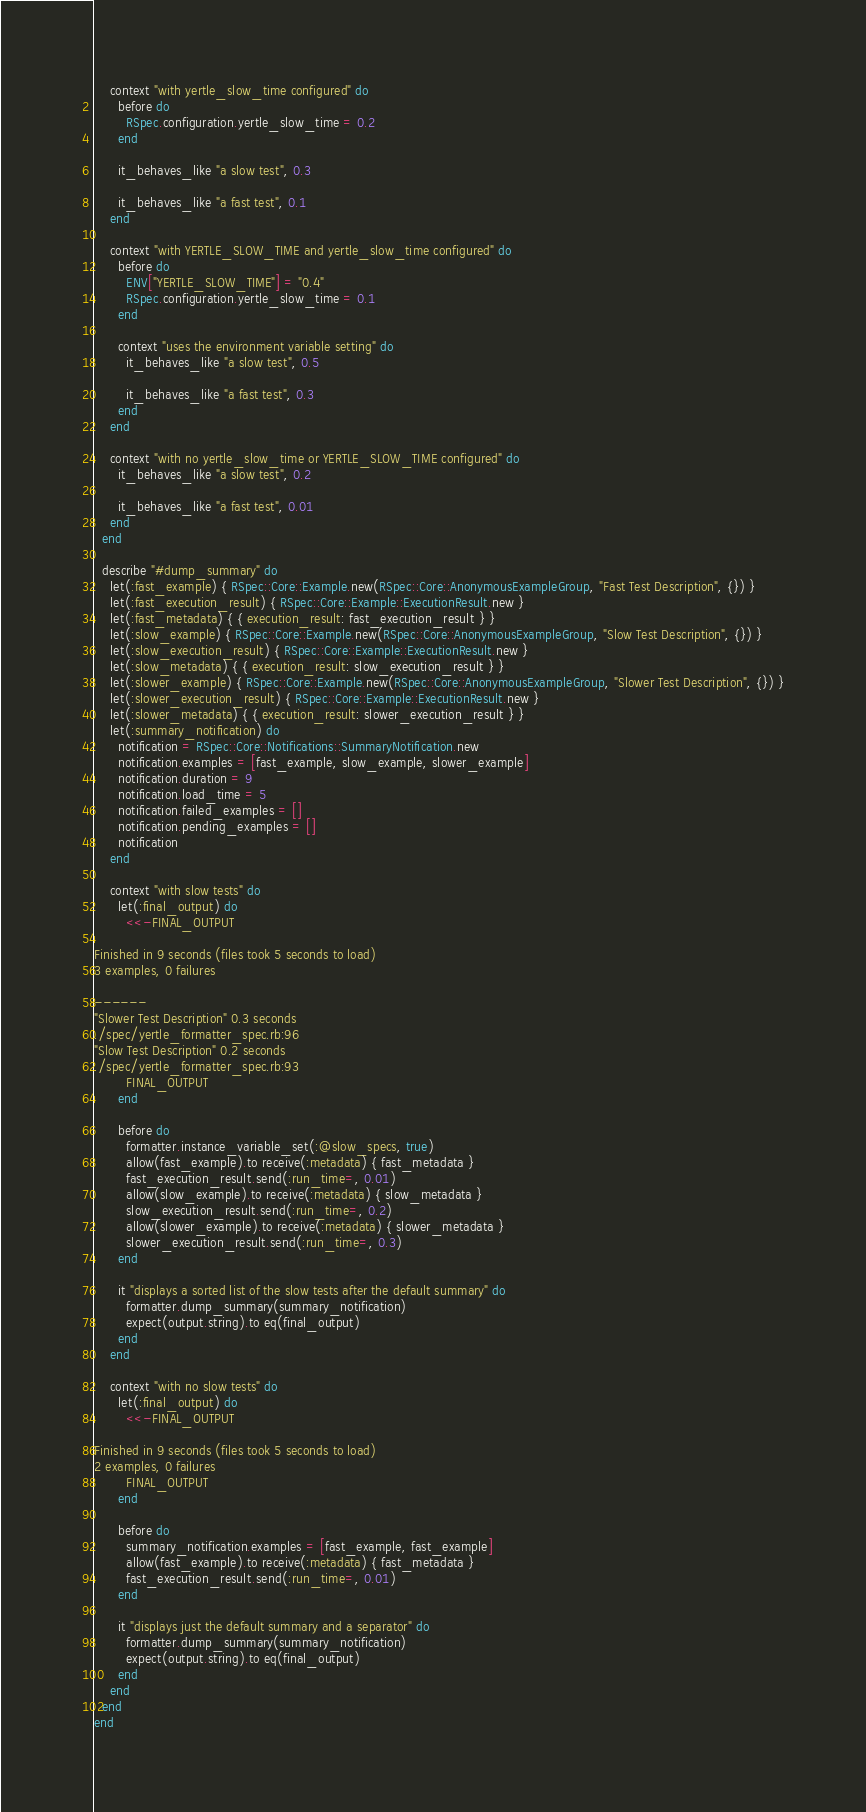Convert code to text. <code><loc_0><loc_0><loc_500><loc_500><_Ruby_>    context "with yertle_slow_time configured" do
      before do
        RSpec.configuration.yertle_slow_time = 0.2
      end

      it_behaves_like "a slow test", 0.3

      it_behaves_like "a fast test", 0.1
    end

    context "with YERTLE_SLOW_TIME and yertle_slow_time configured" do
      before do
        ENV["YERTLE_SLOW_TIME"] = "0.4"
        RSpec.configuration.yertle_slow_time = 0.1
      end

      context "uses the environment variable setting" do
        it_behaves_like "a slow test", 0.5

        it_behaves_like "a fast test", 0.3
      end
    end

    context "with no yertle_slow_time or YERTLE_SLOW_TIME configured" do
      it_behaves_like "a slow test", 0.2

      it_behaves_like "a fast test", 0.01
    end
  end

  describe "#dump_summary" do
    let(:fast_example) { RSpec::Core::Example.new(RSpec::Core::AnonymousExampleGroup, "Fast Test Description", {}) }
    let(:fast_execution_result) { RSpec::Core::Example::ExecutionResult.new }
    let(:fast_metadata) { { execution_result: fast_execution_result } }
    let(:slow_example) { RSpec::Core::Example.new(RSpec::Core::AnonymousExampleGroup, "Slow Test Description", {}) }
    let(:slow_execution_result) { RSpec::Core::Example::ExecutionResult.new }
    let(:slow_metadata) { { execution_result: slow_execution_result } }
    let(:slower_example) { RSpec::Core::Example.new(RSpec::Core::AnonymousExampleGroup, "Slower Test Description", {}) }
    let(:slower_execution_result) { RSpec::Core::Example::ExecutionResult.new }
    let(:slower_metadata) { { execution_result: slower_execution_result } }
    let(:summary_notification) do
      notification = RSpec::Core::Notifications::SummaryNotification.new
      notification.examples = [fast_example, slow_example, slower_example]
      notification.duration = 9
      notification.load_time = 5
      notification.failed_examples = []
      notification.pending_examples = []
      notification
    end

    context "with slow tests" do
      let(:final_output) do
        <<-FINAL_OUTPUT

Finished in 9 seconds (files took 5 seconds to load)
3 examples, 0 failures

------
"Slower Test Description" 0.3 seconds
./spec/yertle_formatter_spec.rb:96
"Slow Test Description" 0.2 seconds
./spec/yertle_formatter_spec.rb:93
        FINAL_OUTPUT
      end

      before do
        formatter.instance_variable_set(:@slow_specs, true)
        allow(fast_example).to receive(:metadata) { fast_metadata }
        fast_execution_result.send(:run_time=, 0.01)
        allow(slow_example).to receive(:metadata) { slow_metadata }
        slow_execution_result.send(:run_time=, 0.2)
        allow(slower_example).to receive(:metadata) { slower_metadata }
        slower_execution_result.send(:run_time=, 0.3)
      end

      it "displays a sorted list of the slow tests after the default summary" do
        formatter.dump_summary(summary_notification)
        expect(output.string).to eq(final_output)
      end
    end

    context "with no slow tests" do
      let(:final_output) do
        <<-FINAL_OUTPUT

Finished in 9 seconds (files took 5 seconds to load)
2 examples, 0 failures
        FINAL_OUTPUT
      end

      before do
        summary_notification.examples = [fast_example, fast_example]
        allow(fast_example).to receive(:metadata) { fast_metadata }
        fast_execution_result.send(:run_time=, 0.01)
      end

      it "displays just the default summary and a separator" do
        formatter.dump_summary(summary_notification)
        expect(output.string).to eq(final_output)
      end
    end
  end
end
</code> 